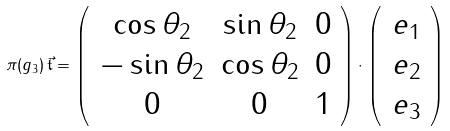<formula> <loc_0><loc_0><loc_500><loc_500>\pi ( g _ { 3 } ) \, \vec { { \mathfrak { t } } } = \left ( \, \begin{array} { c c c } \cos \theta _ { 2 } & \sin \theta _ { 2 } & 0 \\ - \sin \theta _ { 2 } & \cos \theta _ { 2 } & 0 \\ 0 & 0 & 1 \end{array} \right ) \cdot \left ( \, \begin{array} { c } e _ { 1 } \\ e _ { 2 } \\ e _ { 3 } \end{array} \right )</formula> 